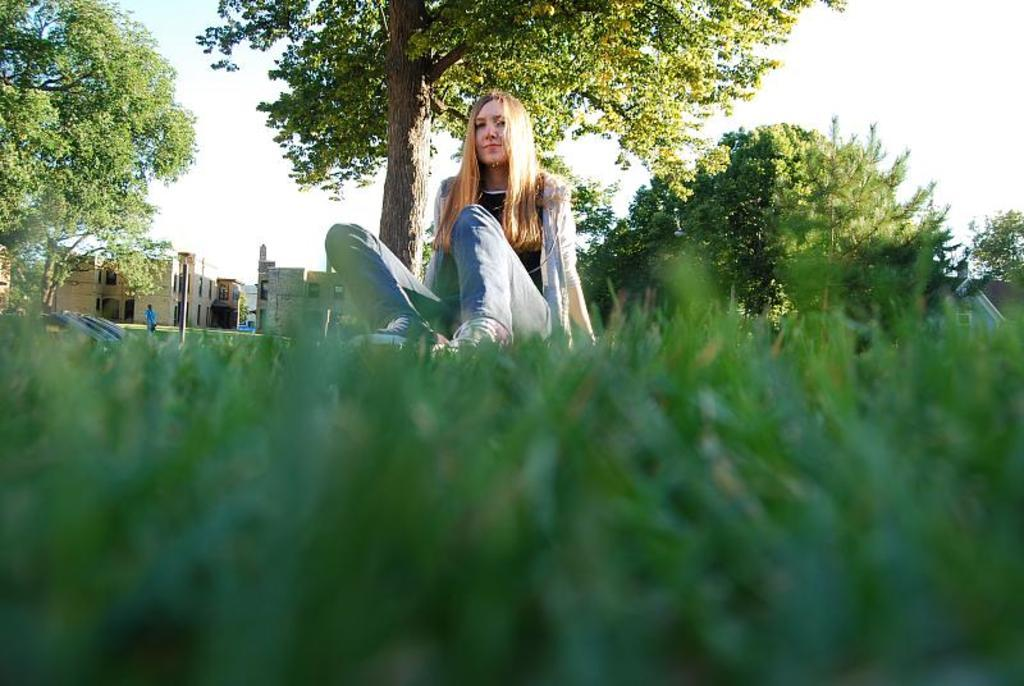What type of surface is visible on the ground in the front of the image? There is grass on the ground in the front of the image. What is the woman in the image doing? There is a woman sitting in the image. What can be seen in the background of the image? There are trees and buildings in the background of the image. What is the condition of the sky in the image? The sky is cloudy in the image. Where is the crib located in the image? There is no crib present in the image. What type of office furniture can be seen in the image? There is no office furniture present in the image. 